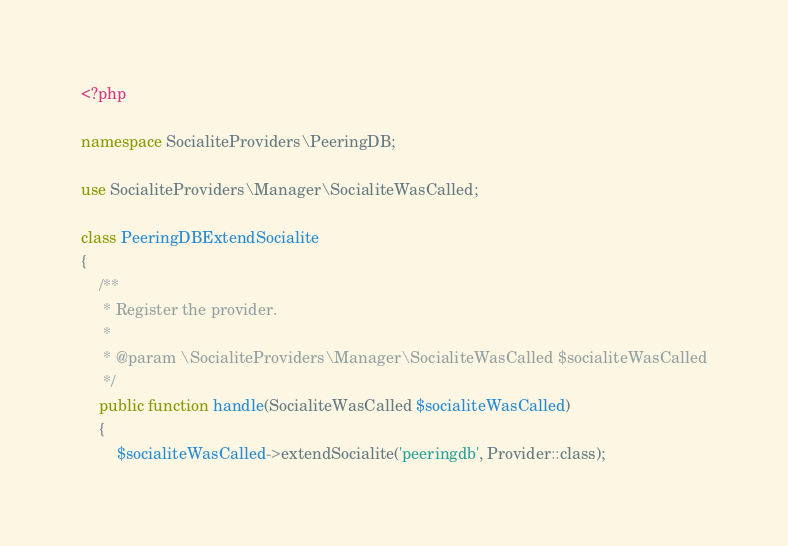<code> <loc_0><loc_0><loc_500><loc_500><_PHP_><?php

namespace SocialiteProviders\PeeringDB;

use SocialiteProviders\Manager\SocialiteWasCalled;

class PeeringDBExtendSocialite
{
    /**
     * Register the provider.
     *
     * @param \SocialiteProviders\Manager\SocialiteWasCalled $socialiteWasCalled
     */
    public function handle(SocialiteWasCalled $socialiteWasCalled)
    {
        $socialiteWasCalled->extendSocialite('peeringdb', Provider::class);</code> 